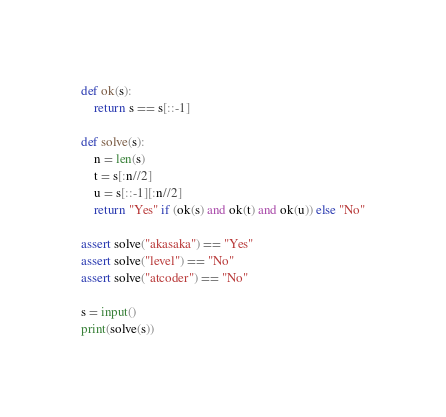<code> <loc_0><loc_0><loc_500><loc_500><_Python_>def ok(s):
    return s == s[::-1]

def solve(s):
    n = len(s)
    t = s[:n//2]
    u = s[::-1][:n//2]
    return "Yes" if (ok(s) and ok(t) and ok(u)) else "No"

assert solve("akasaka") == "Yes"
assert solve("level") == "No"
assert solve("atcoder") == "No"

s = input()
print(solve(s))</code> 